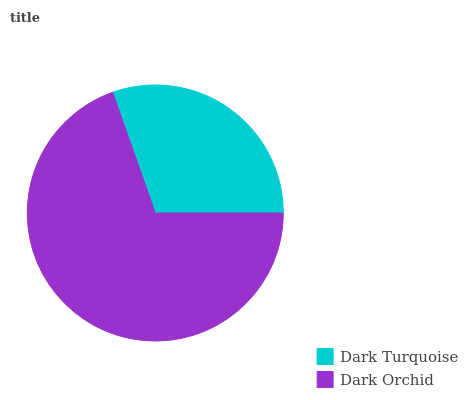Is Dark Turquoise the minimum?
Answer yes or no. Yes. Is Dark Orchid the maximum?
Answer yes or no. Yes. Is Dark Orchid the minimum?
Answer yes or no. No. Is Dark Orchid greater than Dark Turquoise?
Answer yes or no. Yes. Is Dark Turquoise less than Dark Orchid?
Answer yes or no. Yes. Is Dark Turquoise greater than Dark Orchid?
Answer yes or no. No. Is Dark Orchid less than Dark Turquoise?
Answer yes or no. No. Is Dark Orchid the high median?
Answer yes or no. Yes. Is Dark Turquoise the low median?
Answer yes or no. Yes. Is Dark Turquoise the high median?
Answer yes or no. No. Is Dark Orchid the low median?
Answer yes or no. No. 